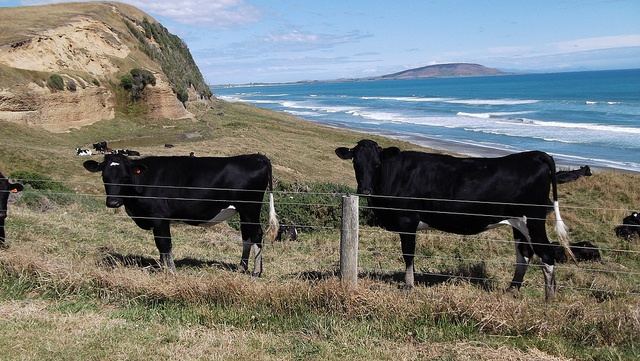Describe the objects in this image and their specific colors. I can see cow in lightblue, black, gray, and darkgray tones, cow in lightblue, black, gray, and darkgray tones, cow in lightblue, black, and gray tones, cow in lightblue, black, gray, and darkgray tones, and cow in lightblue, black, and gray tones in this image. 